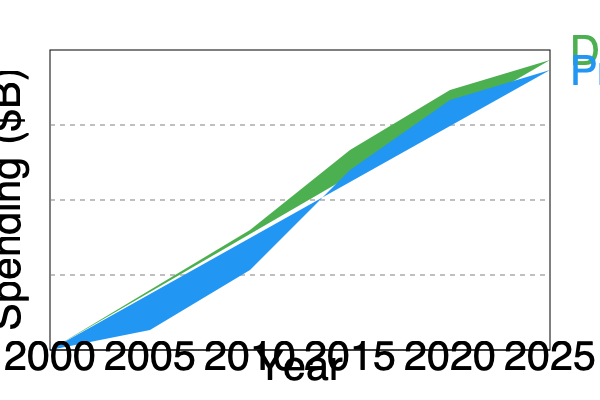Based on the stacked area chart showing the shift from print to digital advertising spending from 2000 to 2025, in which year does digital advertising spending overtake print advertising spending? To determine when digital advertising spending overtakes print advertising spending, we need to analyze the chart step-by-step:

1. The blue area represents print advertising spending, while the green area represents digital advertising spending.

2. We need to find the point where the green area becomes larger than the blue area.

3. Looking at the chart from left to right:
   - In 2000, print spending is significantly higher than digital.
   - The gap narrows as we move towards 2010.
   - Around 2015, we can see that the green area (digital) and blue area (print) are approximately equal in size.
   - After 2015, the green area clearly becomes larger than the blue area.

4. The exact crossover point appears to be slightly before the 2015 mark on the x-axis.

5. Given the options on the x-axis (2000, 2005, 2010, 2015, 2020, 2025), the closest year to this crossover point is 2015.

Therefore, based on the information provided in the chart, digital advertising spending overtakes print advertising spending around 2015.
Answer: 2015 